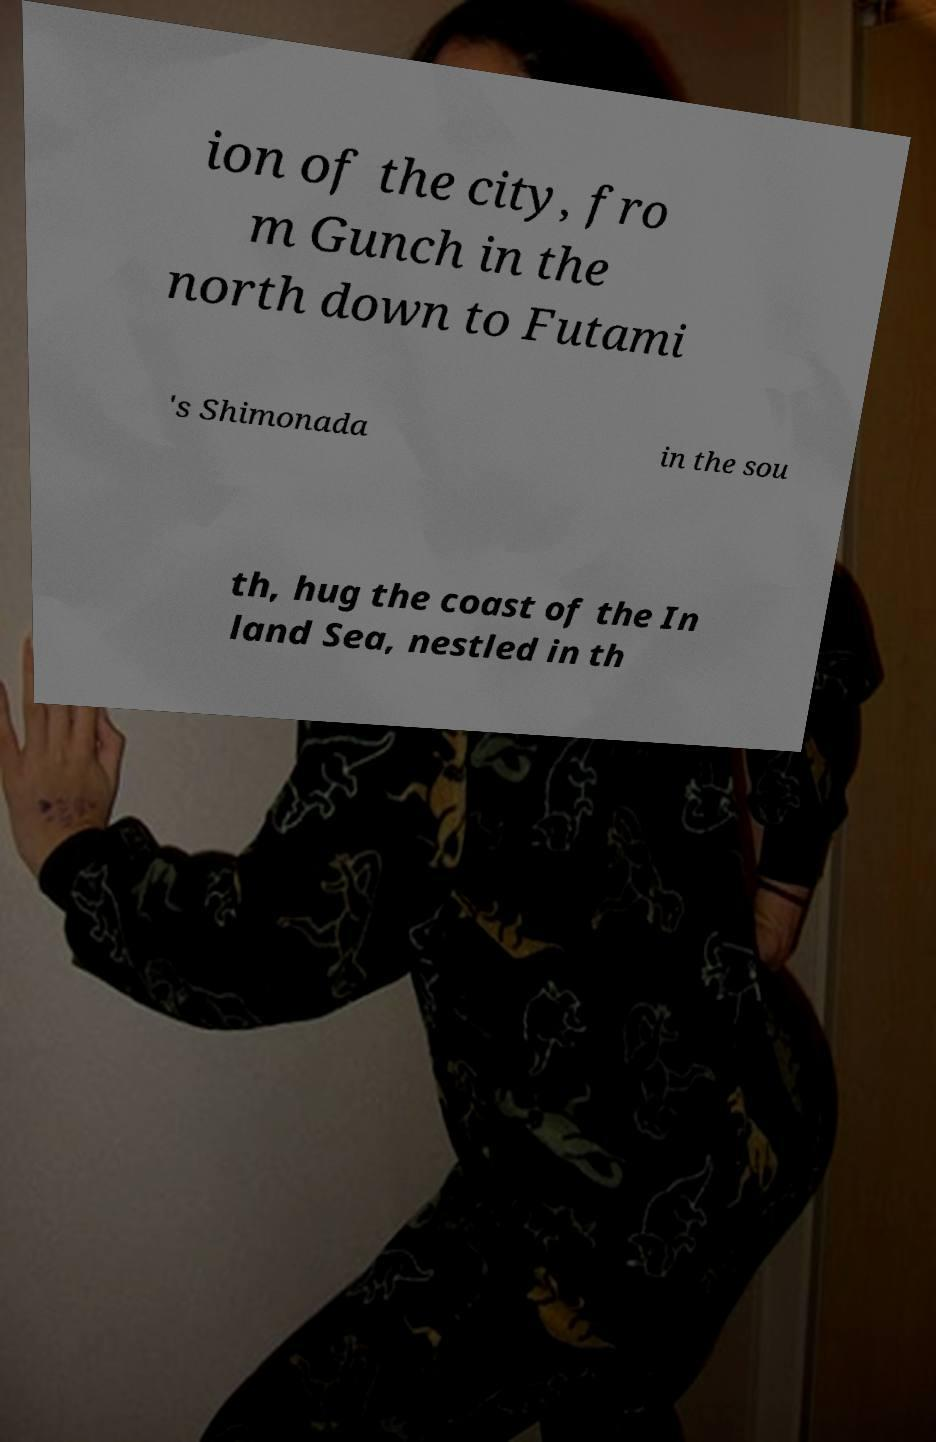What messages or text are displayed in this image? I need them in a readable, typed format. ion of the city, fro m Gunch in the north down to Futami 's Shimonada in the sou th, hug the coast of the In land Sea, nestled in th 